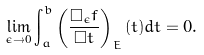<formula> <loc_0><loc_0><loc_500><loc_500>\lim _ { \epsilon \to 0 } \int _ { a } ^ { b } \left ( \frac { \Box _ { \epsilon } f } { \Box t } \right ) _ { E } ( t ) d t = 0 .</formula> 